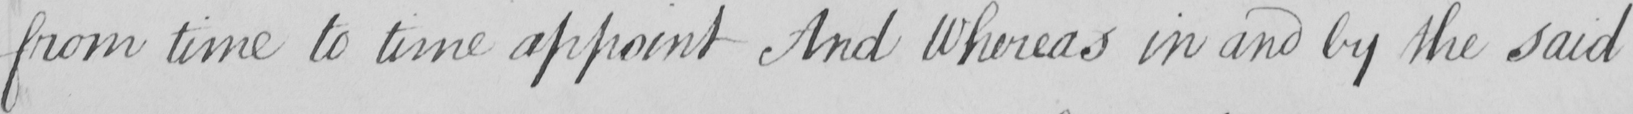What text is written in this handwritten line? from time to time appoint And Whereas in and by the said 